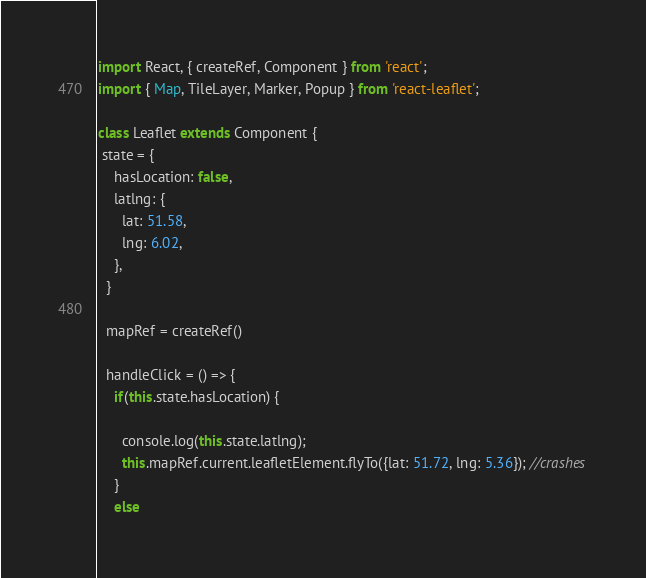Convert code to text. <code><loc_0><loc_0><loc_500><loc_500><_JavaScript_>import React, { createRef, Component } from 'react';
import { Map, TileLayer, Marker, Popup } from 'react-leaflet';

class Leaflet extends Component {
 state = {
    hasLocation: false,
    latlng: {
      lat: 51.58,
      lng: 6.02,
    },
  }

  mapRef = createRef()

  handleClick = () => {
    if(this.state.hasLocation) {

      console.log(this.state.latlng);
      this.mapRef.current.leafletElement.flyTo({lat: 51.72, lng: 5.36}); //crashes
    }
    else</code> 